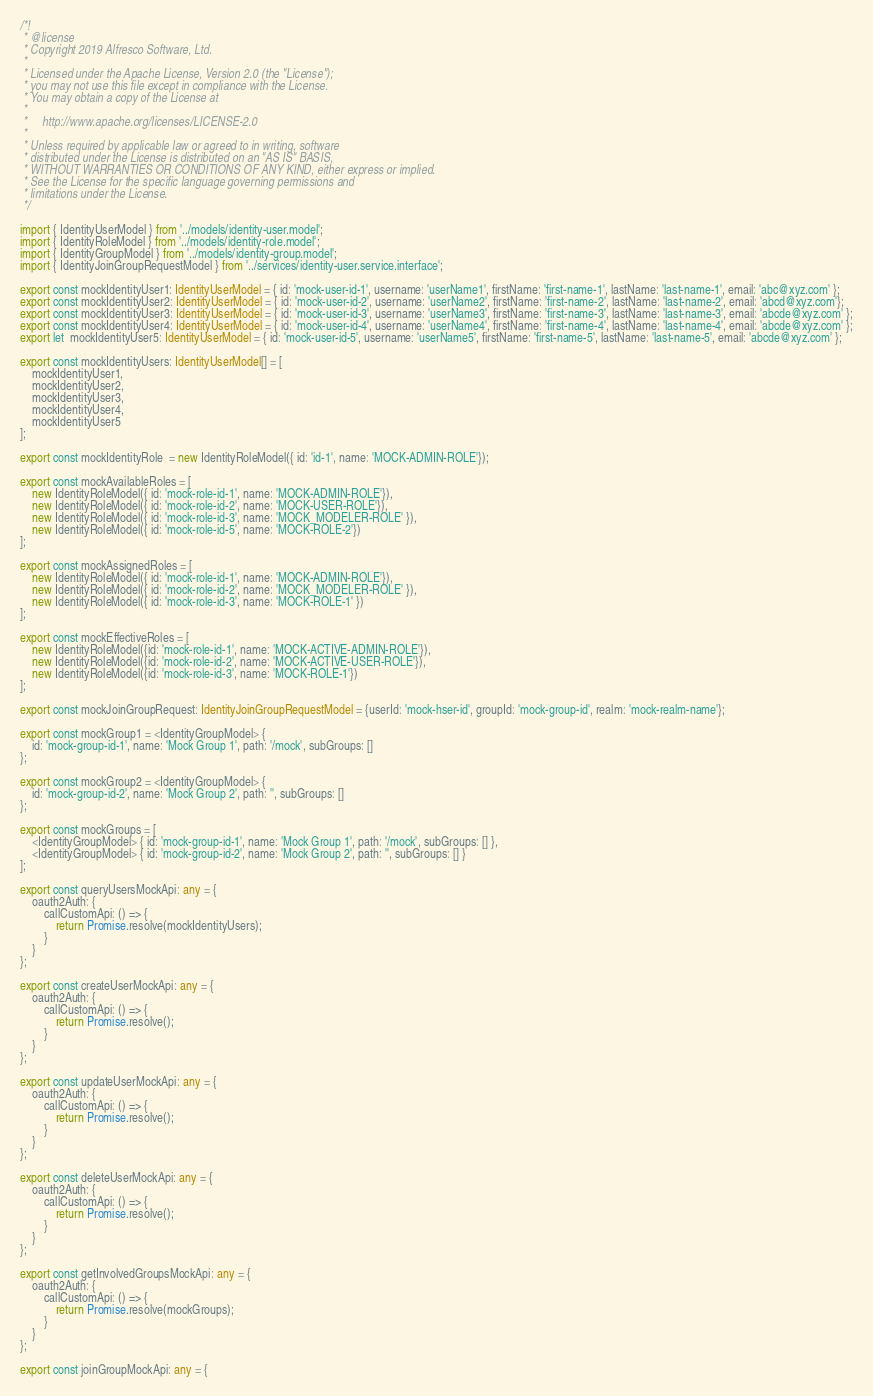<code> <loc_0><loc_0><loc_500><loc_500><_TypeScript_>/*!
 * @license
 * Copyright 2019 Alfresco Software, Ltd.
 *
 * Licensed under the Apache License, Version 2.0 (the "License");
 * you may not use this file except in compliance with the License.
 * You may obtain a copy of the License at
 *
 *     http://www.apache.org/licenses/LICENSE-2.0
 *
 * Unless required by applicable law or agreed to in writing, software
 * distributed under the License is distributed on an "AS IS" BASIS,
 * WITHOUT WARRANTIES OR CONDITIONS OF ANY KIND, either express or implied.
 * See the License for the specific language governing permissions and
 * limitations under the License.
 */

import { IdentityUserModel } from '../models/identity-user.model';
import { IdentityRoleModel } from '../models/identity-role.model';
import { IdentityGroupModel } from '../models/identity-group.model';
import { IdentityJoinGroupRequestModel } from '../services/identity-user.service.interface';

export const mockIdentityUser1: IdentityUserModel = { id: 'mock-user-id-1', username: 'userName1', firstName: 'first-name-1', lastName: 'last-name-1', email: 'abc@xyz.com' };
export const mockIdentityUser2: IdentityUserModel = { id: 'mock-user-id-2', username: 'userName2', firstName: 'first-name-2', lastName: 'last-name-2', email: 'abcd@xyz.com'};
export const mockIdentityUser3: IdentityUserModel = { id: 'mock-user-id-3', username: 'userName3', firstName: 'first-name-3', lastName: 'last-name-3', email: 'abcde@xyz.com' };
export const mockIdentityUser4: IdentityUserModel = { id: 'mock-user-id-4', username: 'userName4', firstName: 'first-name-4', lastName: 'last-name-4', email: 'abcde@xyz.com' };
export let  mockIdentityUser5: IdentityUserModel = { id: 'mock-user-id-5', username: 'userName5', firstName: 'first-name-5', lastName: 'last-name-5', email: 'abcde@xyz.com' };

export const mockIdentityUsers: IdentityUserModel[] = [
    mockIdentityUser1,
    mockIdentityUser2,
    mockIdentityUser3,
    mockIdentityUser4,
    mockIdentityUser5
];

export const mockIdentityRole  = new IdentityRoleModel({ id: 'id-1', name: 'MOCK-ADMIN-ROLE'});

export const mockAvailableRoles = [
    new IdentityRoleModel({ id: 'mock-role-id-1', name: 'MOCK-ADMIN-ROLE'}),
    new IdentityRoleModel({ id: 'mock-role-id-2', name: 'MOCK-USER-ROLE'}),
    new IdentityRoleModel({ id: 'mock-role-id-3', name: 'MOCK_MODELER-ROLE' }),
    new IdentityRoleModel({ id: 'mock-role-id-5', name: 'MOCK-ROLE-2'})
];

export const mockAssignedRoles = [
    new IdentityRoleModel({ id: 'mock-role-id-1', name: 'MOCK-ADMIN-ROLE'}),
    new IdentityRoleModel({ id: 'mock-role-id-2', name: 'MOCK_MODELER-ROLE' }),
    new IdentityRoleModel({ id: 'mock-role-id-3', name: 'MOCK-ROLE-1' })
];

export const mockEffectiveRoles = [
    new IdentityRoleModel({id: 'mock-role-id-1', name: 'MOCK-ACTIVE-ADMIN-ROLE'}),
    new IdentityRoleModel({id: 'mock-role-id-2', name: 'MOCK-ACTIVE-USER-ROLE'}),
    new IdentityRoleModel({id: 'mock-role-id-3', name: 'MOCK-ROLE-1'})
];

export const mockJoinGroupRequest: IdentityJoinGroupRequestModel = {userId: 'mock-hser-id', groupId: 'mock-group-id', realm: 'mock-realm-name'};

export const mockGroup1 = <IdentityGroupModel> {
    id: 'mock-group-id-1', name: 'Mock Group 1', path: '/mock', subGroups: []
};

export const mockGroup2 = <IdentityGroupModel> {
    id: 'mock-group-id-2', name: 'Mock Group 2', path: '', subGroups: []
};

export const mockGroups = [
    <IdentityGroupModel> { id: 'mock-group-id-1', name: 'Mock Group 1', path: '/mock', subGroups: [] },
    <IdentityGroupModel> { id: 'mock-group-id-2', name: 'Mock Group 2', path: '', subGroups: [] }
];

export const queryUsersMockApi: any = {
    oauth2Auth: {
        callCustomApi: () => {
            return Promise.resolve(mockIdentityUsers);
        }
    }
};

export const createUserMockApi: any = {
    oauth2Auth: {
        callCustomApi: () => {
            return Promise.resolve();
        }
    }
};

export const updateUserMockApi: any = {
    oauth2Auth: {
        callCustomApi: () => {
            return Promise.resolve();
        }
    }
};

export const deleteUserMockApi: any = {
    oauth2Auth: {
        callCustomApi: () => {
            return Promise.resolve();
        }
    }
};

export const getInvolvedGroupsMockApi: any = {
    oauth2Auth: {
        callCustomApi: () => {
            return Promise.resolve(mockGroups);
        }
    }
};

export const joinGroupMockApi: any = {</code> 